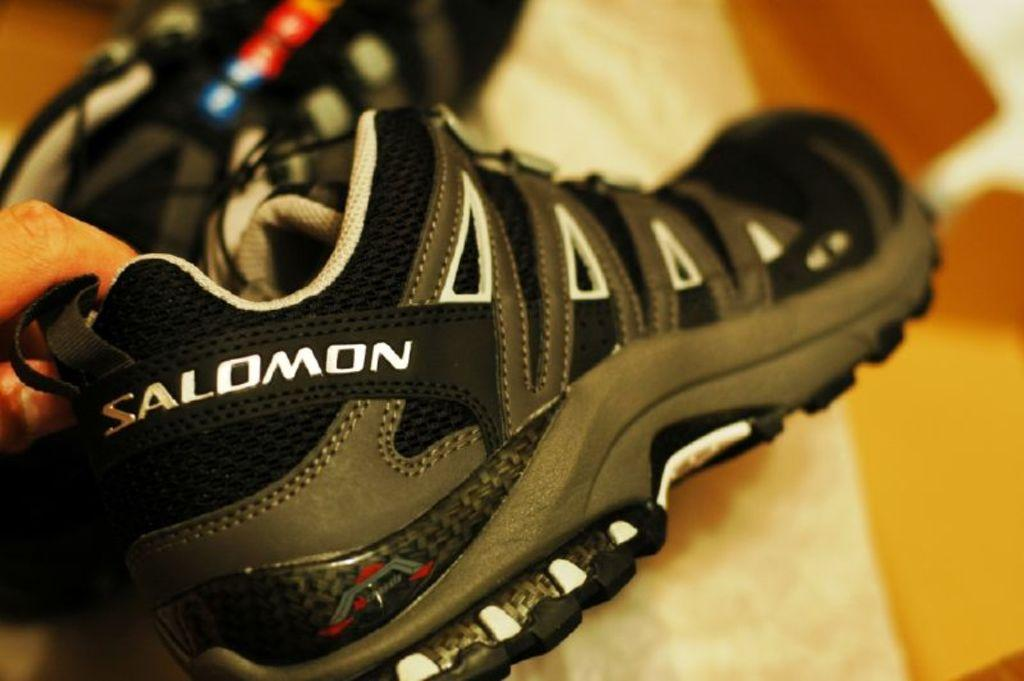What type of footwear is in the picture? There is a pair of shoes in the picture. What colors are the shoes? The shoes are black and dark green in color. What is written on the shoes? The shoes have the name "salmon" on them. Where are the shoes located in the picture? The shoes are placed on the floor. What channel do the shoes use to communicate with each other? The shoes do not communicate with each other, and there is no channel present in the image. 